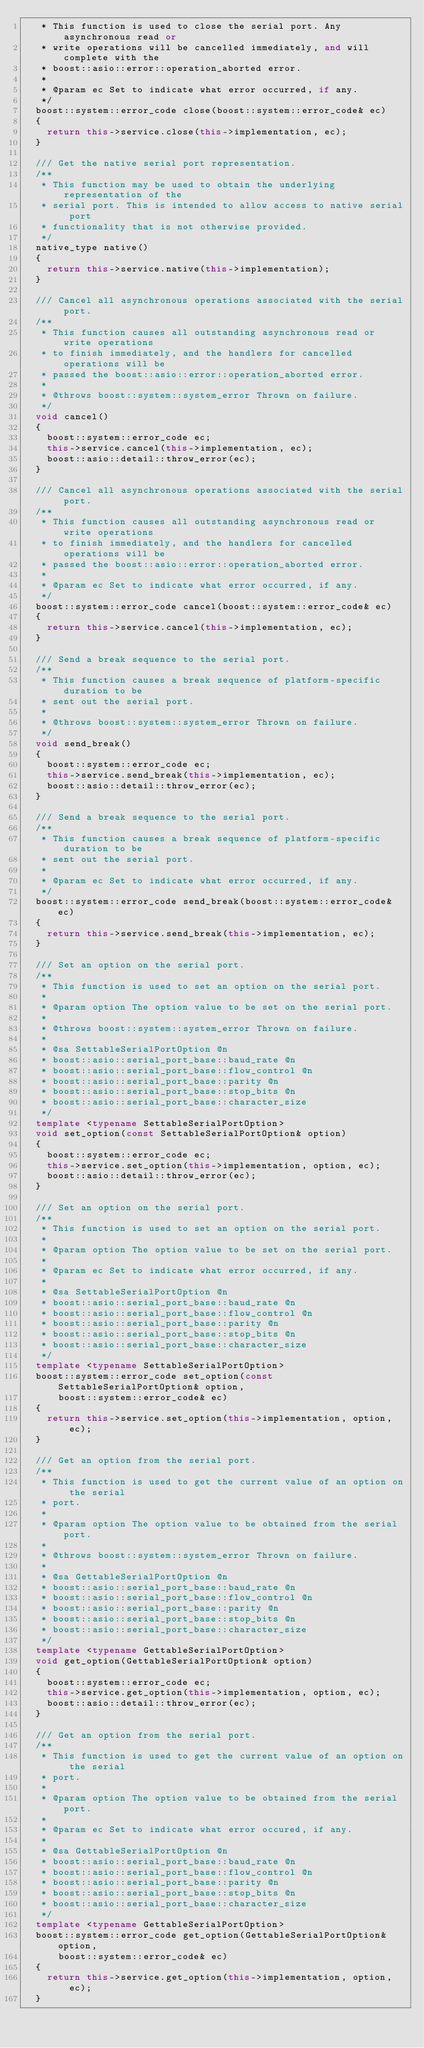Convert code to text. <code><loc_0><loc_0><loc_500><loc_500><_C++_>   * This function is used to close the serial port. Any asynchronous read or
   * write operations will be cancelled immediately, and will complete with the
   * boost::asio::error::operation_aborted error.
   *
   * @param ec Set to indicate what error occurred, if any.
   */
  boost::system::error_code close(boost::system::error_code& ec)
  {
    return this->service.close(this->implementation, ec);
  }

  /// Get the native serial port representation.
  /**
   * This function may be used to obtain the underlying representation of the
   * serial port. This is intended to allow access to native serial port
   * functionality that is not otherwise provided.
   */
  native_type native()
  {
    return this->service.native(this->implementation);
  }

  /// Cancel all asynchronous operations associated with the serial port.
  /**
   * This function causes all outstanding asynchronous read or write operations
   * to finish immediately, and the handlers for cancelled operations will be
   * passed the boost::asio::error::operation_aborted error.
   *
   * @throws boost::system::system_error Thrown on failure.
   */
  void cancel()
  {
    boost::system::error_code ec;
    this->service.cancel(this->implementation, ec);
    boost::asio::detail::throw_error(ec);
  }

  /// Cancel all asynchronous operations associated with the serial port.
  /**
   * This function causes all outstanding asynchronous read or write operations
   * to finish immediately, and the handlers for cancelled operations will be
   * passed the boost::asio::error::operation_aborted error.
   *
   * @param ec Set to indicate what error occurred, if any.
   */
  boost::system::error_code cancel(boost::system::error_code& ec)
  {
    return this->service.cancel(this->implementation, ec);
  }

  /// Send a break sequence to the serial port.
  /**
   * This function causes a break sequence of platform-specific duration to be
   * sent out the serial port.
   *
   * @throws boost::system::system_error Thrown on failure.
   */
  void send_break()
  {
    boost::system::error_code ec;
    this->service.send_break(this->implementation, ec);
    boost::asio::detail::throw_error(ec);
  }

  /// Send a break sequence to the serial port.
  /**
   * This function causes a break sequence of platform-specific duration to be
   * sent out the serial port.
   *
   * @param ec Set to indicate what error occurred, if any.
   */
  boost::system::error_code send_break(boost::system::error_code& ec)
  {
    return this->service.send_break(this->implementation, ec);
  }

  /// Set an option on the serial port.
  /**
   * This function is used to set an option on the serial port.
   *
   * @param option The option value to be set on the serial port.
   *
   * @throws boost::system::system_error Thrown on failure.
   *
   * @sa SettableSerialPortOption @n
   * boost::asio::serial_port_base::baud_rate @n
   * boost::asio::serial_port_base::flow_control @n
   * boost::asio::serial_port_base::parity @n
   * boost::asio::serial_port_base::stop_bits @n
   * boost::asio::serial_port_base::character_size
   */
  template <typename SettableSerialPortOption>
  void set_option(const SettableSerialPortOption& option)
  {
    boost::system::error_code ec;
    this->service.set_option(this->implementation, option, ec);
    boost::asio::detail::throw_error(ec);
  }

  /// Set an option on the serial port.
  /**
   * This function is used to set an option on the serial port.
   *
   * @param option The option value to be set on the serial port.
   *
   * @param ec Set to indicate what error occurred, if any.
   *
   * @sa SettableSerialPortOption @n
   * boost::asio::serial_port_base::baud_rate @n
   * boost::asio::serial_port_base::flow_control @n
   * boost::asio::serial_port_base::parity @n
   * boost::asio::serial_port_base::stop_bits @n
   * boost::asio::serial_port_base::character_size
   */
  template <typename SettableSerialPortOption>
  boost::system::error_code set_option(const SettableSerialPortOption& option,
      boost::system::error_code& ec)
  {
    return this->service.set_option(this->implementation, option, ec);
  }

  /// Get an option from the serial port.
  /**
   * This function is used to get the current value of an option on the serial
   * port.
   *
   * @param option The option value to be obtained from the serial port.
   *
   * @throws boost::system::system_error Thrown on failure.
   *
   * @sa GettableSerialPortOption @n
   * boost::asio::serial_port_base::baud_rate @n
   * boost::asio::serial_port_base::flow_control @n
   * boost::asio::serial_port_base::parity @n
   * boost::asio::serial_port_base::stop_bits @n
   * boost::asio::serial_port_base::character_size
   */
  template <typename GettableSerialPortOption>
  void get_option(GettableSerialPortOption& option)
  {
    boost::system::error_code ec;
    this->service.get_option(this->implementation, option, ec);
    boost::asio::detail::throw_error(ec);
  }

  /// Get an option from the serial port.
  /**
   * This function is used to get the current value of an option on the serial
   * port.
   *
   * @param option The option value to be obtained from the serial port.
   *
   * @param ec Set to indicate what error occured, if any.
   *
   * @sa GettableSerialPortOption @n
   * boost::asio::serial_port_base::baud_rate @n
   * boost::asio::serial_port_base::flow_control @n
   * boost::asio::serial_port_base::parity @n
   * boost::asio::serial_port_base::stop_bits @n
   * boost::asio::serial_port_base::character_size
   */
  template <typename GettableSerialPortOption>
  boost::system::error_code get_option(GettableSerialPortOption& option,
      boost::system::error_code& ec)
  {
    return this->service.get_option(this->implementation, option, ec);
  }
</code> 